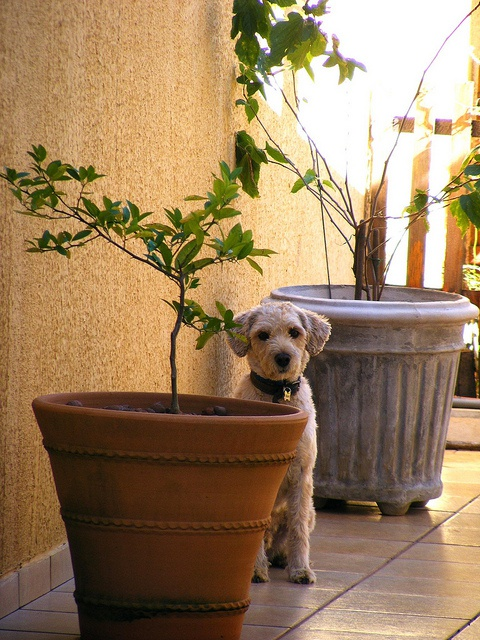Describe the objects in this image and their specific colors. I can see potted plant in brown, maroon, black, olive, and tan tones, potted plant in brown, gray, olive, black, and white tones, and dog in brown, gray, maroon, and black tones in this image. 